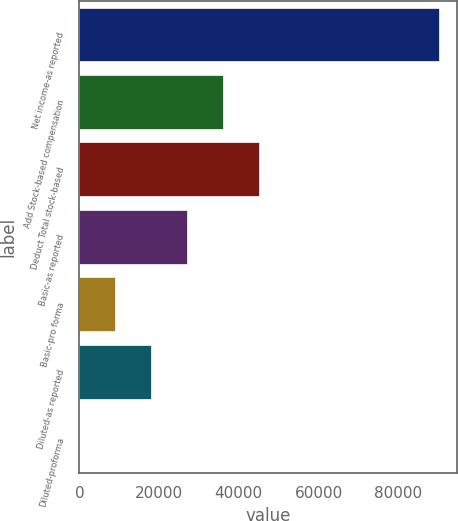<chart> <loc_0><loc_0><loc_500><loc_500><bar_chart><fcel>Net income-as reported<fcel>Add Stock-based compensation<fcel>Deduct Total stock-based<fcel>Basic-as reported<fcel>Basic-pro forma<fcel>Diluted-as reported<fcel>Diluted-proforma<nl><fcel>90313<fcel>36125.4<fcel>45156.7<fcel>27094.2<fcel>9031.67<fcel>18062.9<fcel>0.41<nl></chart> 